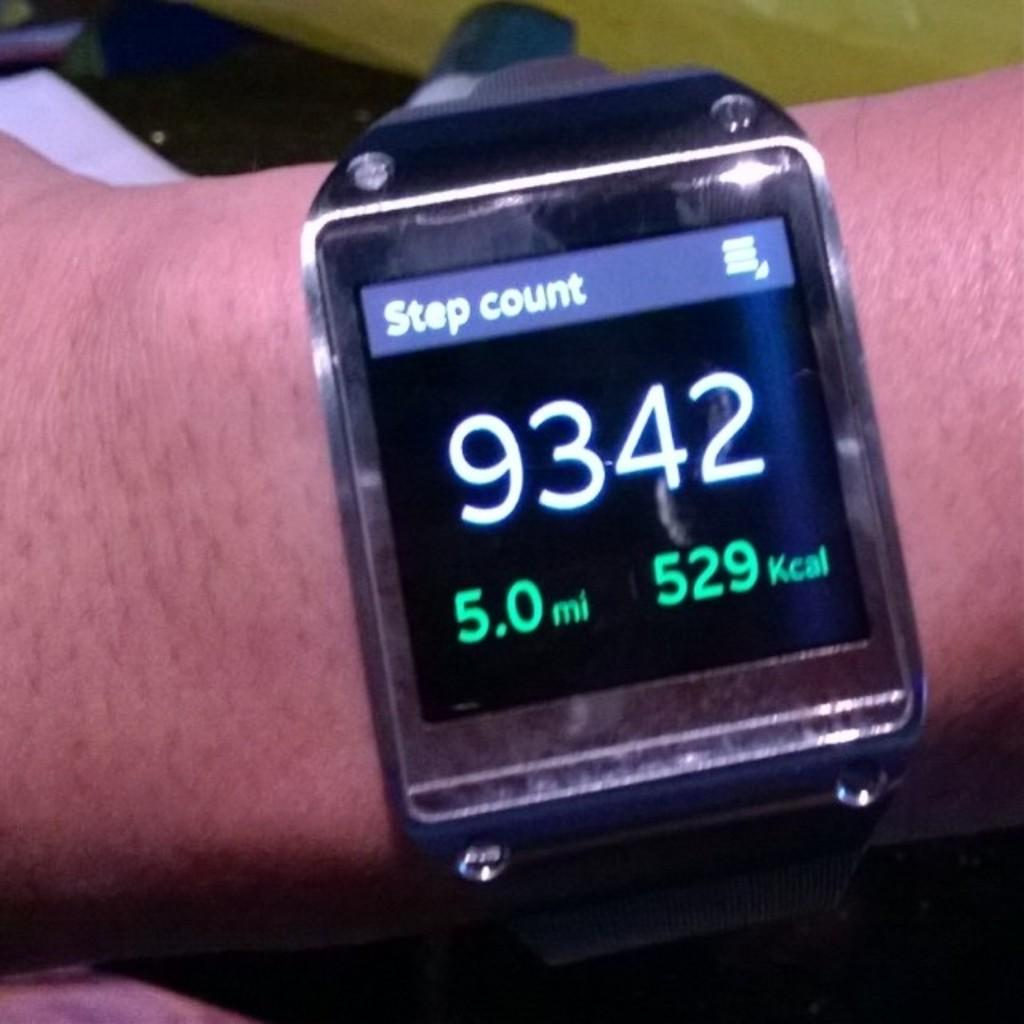<image>
Give a short and clear explanation of the subsequent image. A smart watch on someone's arm is showing a step count of 9342. 